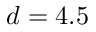<formula> <loc_0><loc_0><loc_500><loc_500>d = 4 . 5</formula> 